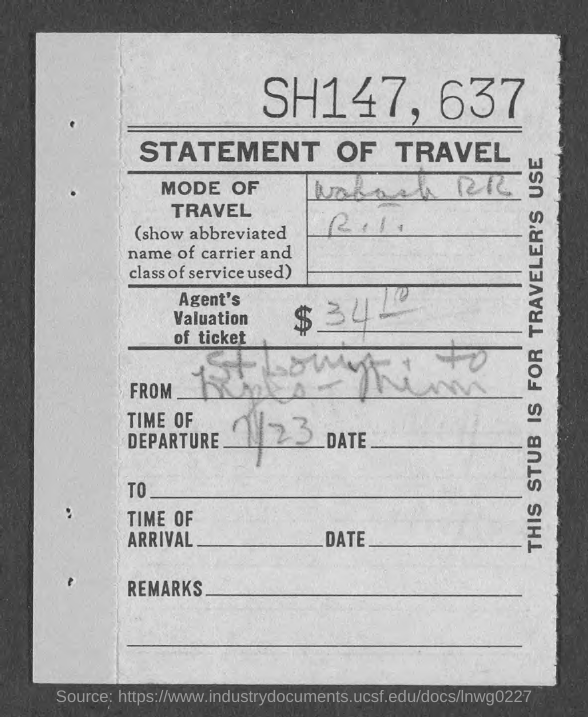Mention a couple of crucial points in this snapshot. The time of departure is 11:23. The title of the document is 'Statement of Travel'. 